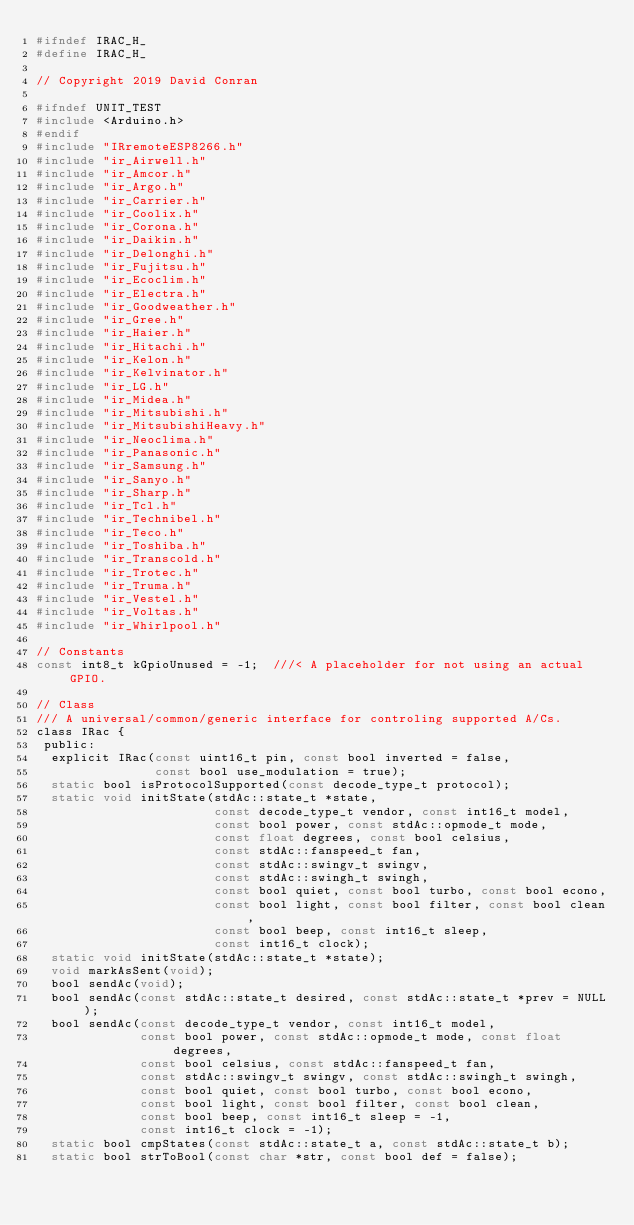Convert code to text. <code><loc_0><loc_0><loc_500><loc_500><_C_>#ifndef IRAC_H_
#define IRAC_H_

// Copyright 2019 David Conran

#ifndef UNIT_TEST
#include <Arduino.h>
#endif
#include "IRremoteESP8266.h"
#include "ir_Airwell.h"
#include "ir_Amcor.h"
#include "ir_Argo.h"
#include "ir_Carrier.h"
#include "ir_Coolix.h"
#include "ir_Corona.h"
#include "ir_Daikin.h"
#include "ir_Delonghi.h"
#include "ir_Fujitsu.h"
#include "ir_Ecoclim.h"
#include "ir_Electra.h"
#include "ir_Goodweather.h"
#include "ir_Gree.h"
#include "ir_Haier.h"
#include "ir_Hitachi.h"
#include "ir_Kelon.h"
#include "ir_Kelvinator.h"
#include "ir_LG.h"
#include "ir_Midea.h"
#include "ir_Mitsubishi.h"
#include "ir_MitsubishiHeavy.h"
#include "ir_Neoclima.h"
#include "ir_Panasonic.h"
#include "ir_Samsung.h"
#include "ir_Sanyo.h"
#include "ir_Sharp.h"
#include "ir_Tcl.h"
#include "ir_Technibel.h"
#include "ir_Teco.h"
#include "ir_Toshiba.h"
#include "ir_Transcold.h"
#include "ir_Trotec.h"
#include "ir_Truma.h"
#include "ir_Vestel.h"
#include "ir_Voltas.h"
#include "ir_Whirlpool.h"

// Constants
const int8_t kGpioUnused = -1;  ///< A placeholder for not using an actual GPIO.

// Class
/// A universal/common/generic interface for controling supported A/Cs.
class IRac {
 public:
  explicit IRac(const uint16_t pin, const bool inverted = false,
                const bool use_modulation = true);
  static bool isProtocolSupported(const decode_type_t protocol);
  static void initState(stdAc::state_t *state,
                        const decode_type_t vendor, const int16_t model,
                        const bool power, const stdAc::opmode_t mode,
                        const float degrees, const bool celsius,
                        const stdAc::fanspeed_t fan,
                        const stdAc::swingv_t swingv,
                        const stdAc::swingh_t swingh,
                        const bool quiet, const bool turbo, const bool econo,
                        const bool light, const bool filter, const bool clean,
                        const bool beep, const int16_t sleep,
                        const int16_t clock);
  static void initState(stdAc::state_t *state);
  void markAsSent(void);
  bool sendAc(void);
  bool sendAc(const stdAc::state_t desired, const stdAc::state_t *prev = NULL);
  bool sendAc(const decode_type_t vendor, const int16_t model,
              const bool power, const stdAc::opmode_t mode, const float degrees,
              const bool celsius, const stdAc::fanspeed_t fan,
              const stdAc::swingv_t swingv, const stdAc::swingh_t swingh,
              const bool quiet, const bool turbo, const bool econo,
              const bool light, const bool filter, const bool clean,
              const bool beep, const int16_t sleep = -1,
              const int16_t clock = -1);
  static bool cmpStates(const stdAc::state_t a, const stdAc::state_t b);
  static bool strToBool(const char *str, const bool def = false);</code> 